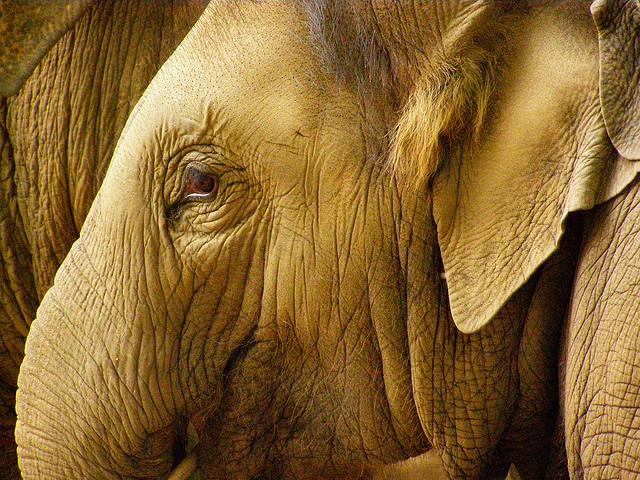What kind of animal is this?
Concise answer only. Elephant. Does this animal have tusks?
Keep it brief. No. Is this animal furry?
Be succinct. No. 